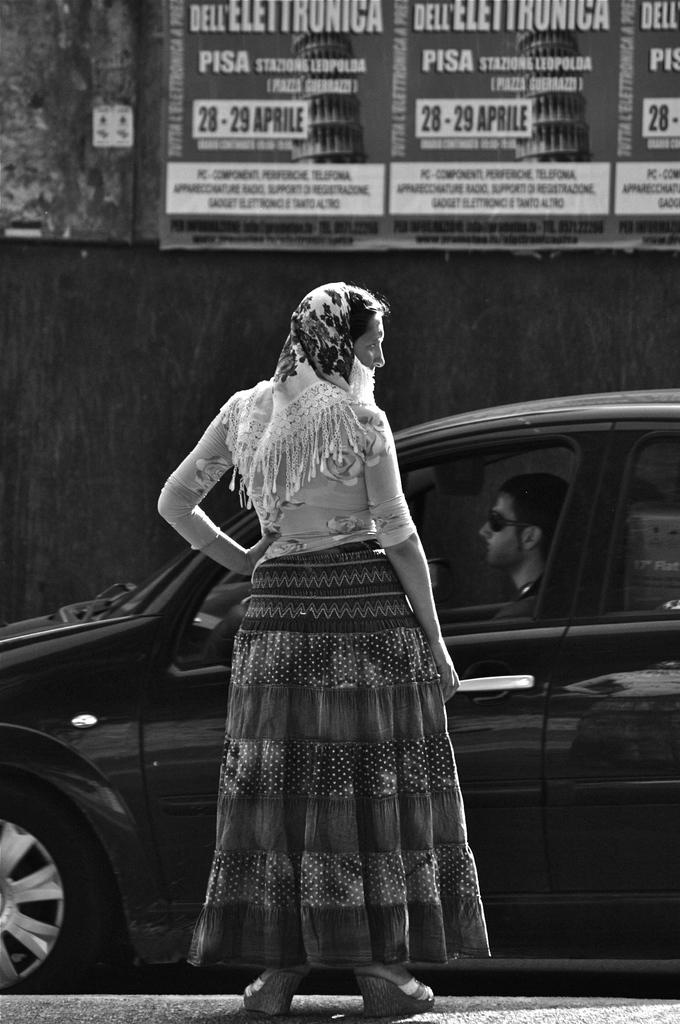Who is the main subject in the image? There is a lady in the image. What is the lady wearing? The lady is wearing a white shirt and a gown. Can you describe the position of the second lady in the image? There is another lady in front of the first lady. What else can be seen in the image? There is a car in the image, and a guy is inside the car. What is the guy wearing? The guy is wearing spectacles. What type of coach can be seen in the image? There is no coach present in the image; it features a lady, another lady, a car, and a guy wearing spectacles. What is the stretch of the gown worn by the lady in the image? The provided facts do not mention the length or stretch of the gown worn by the lady. 